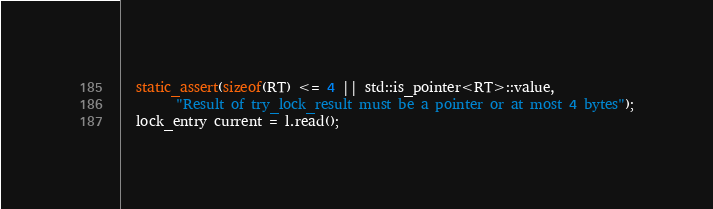Convert code to text. <code><loc_0><loc_0><loc_500><loc_500><_C_>  static_assert(sizeof(RT) <= 4 || std::is_pointer<RT>::value,
 		"Result of try_lock_result must be a pointer or at most 4 bytes");
  lock_entry current = l.read();
</code> 